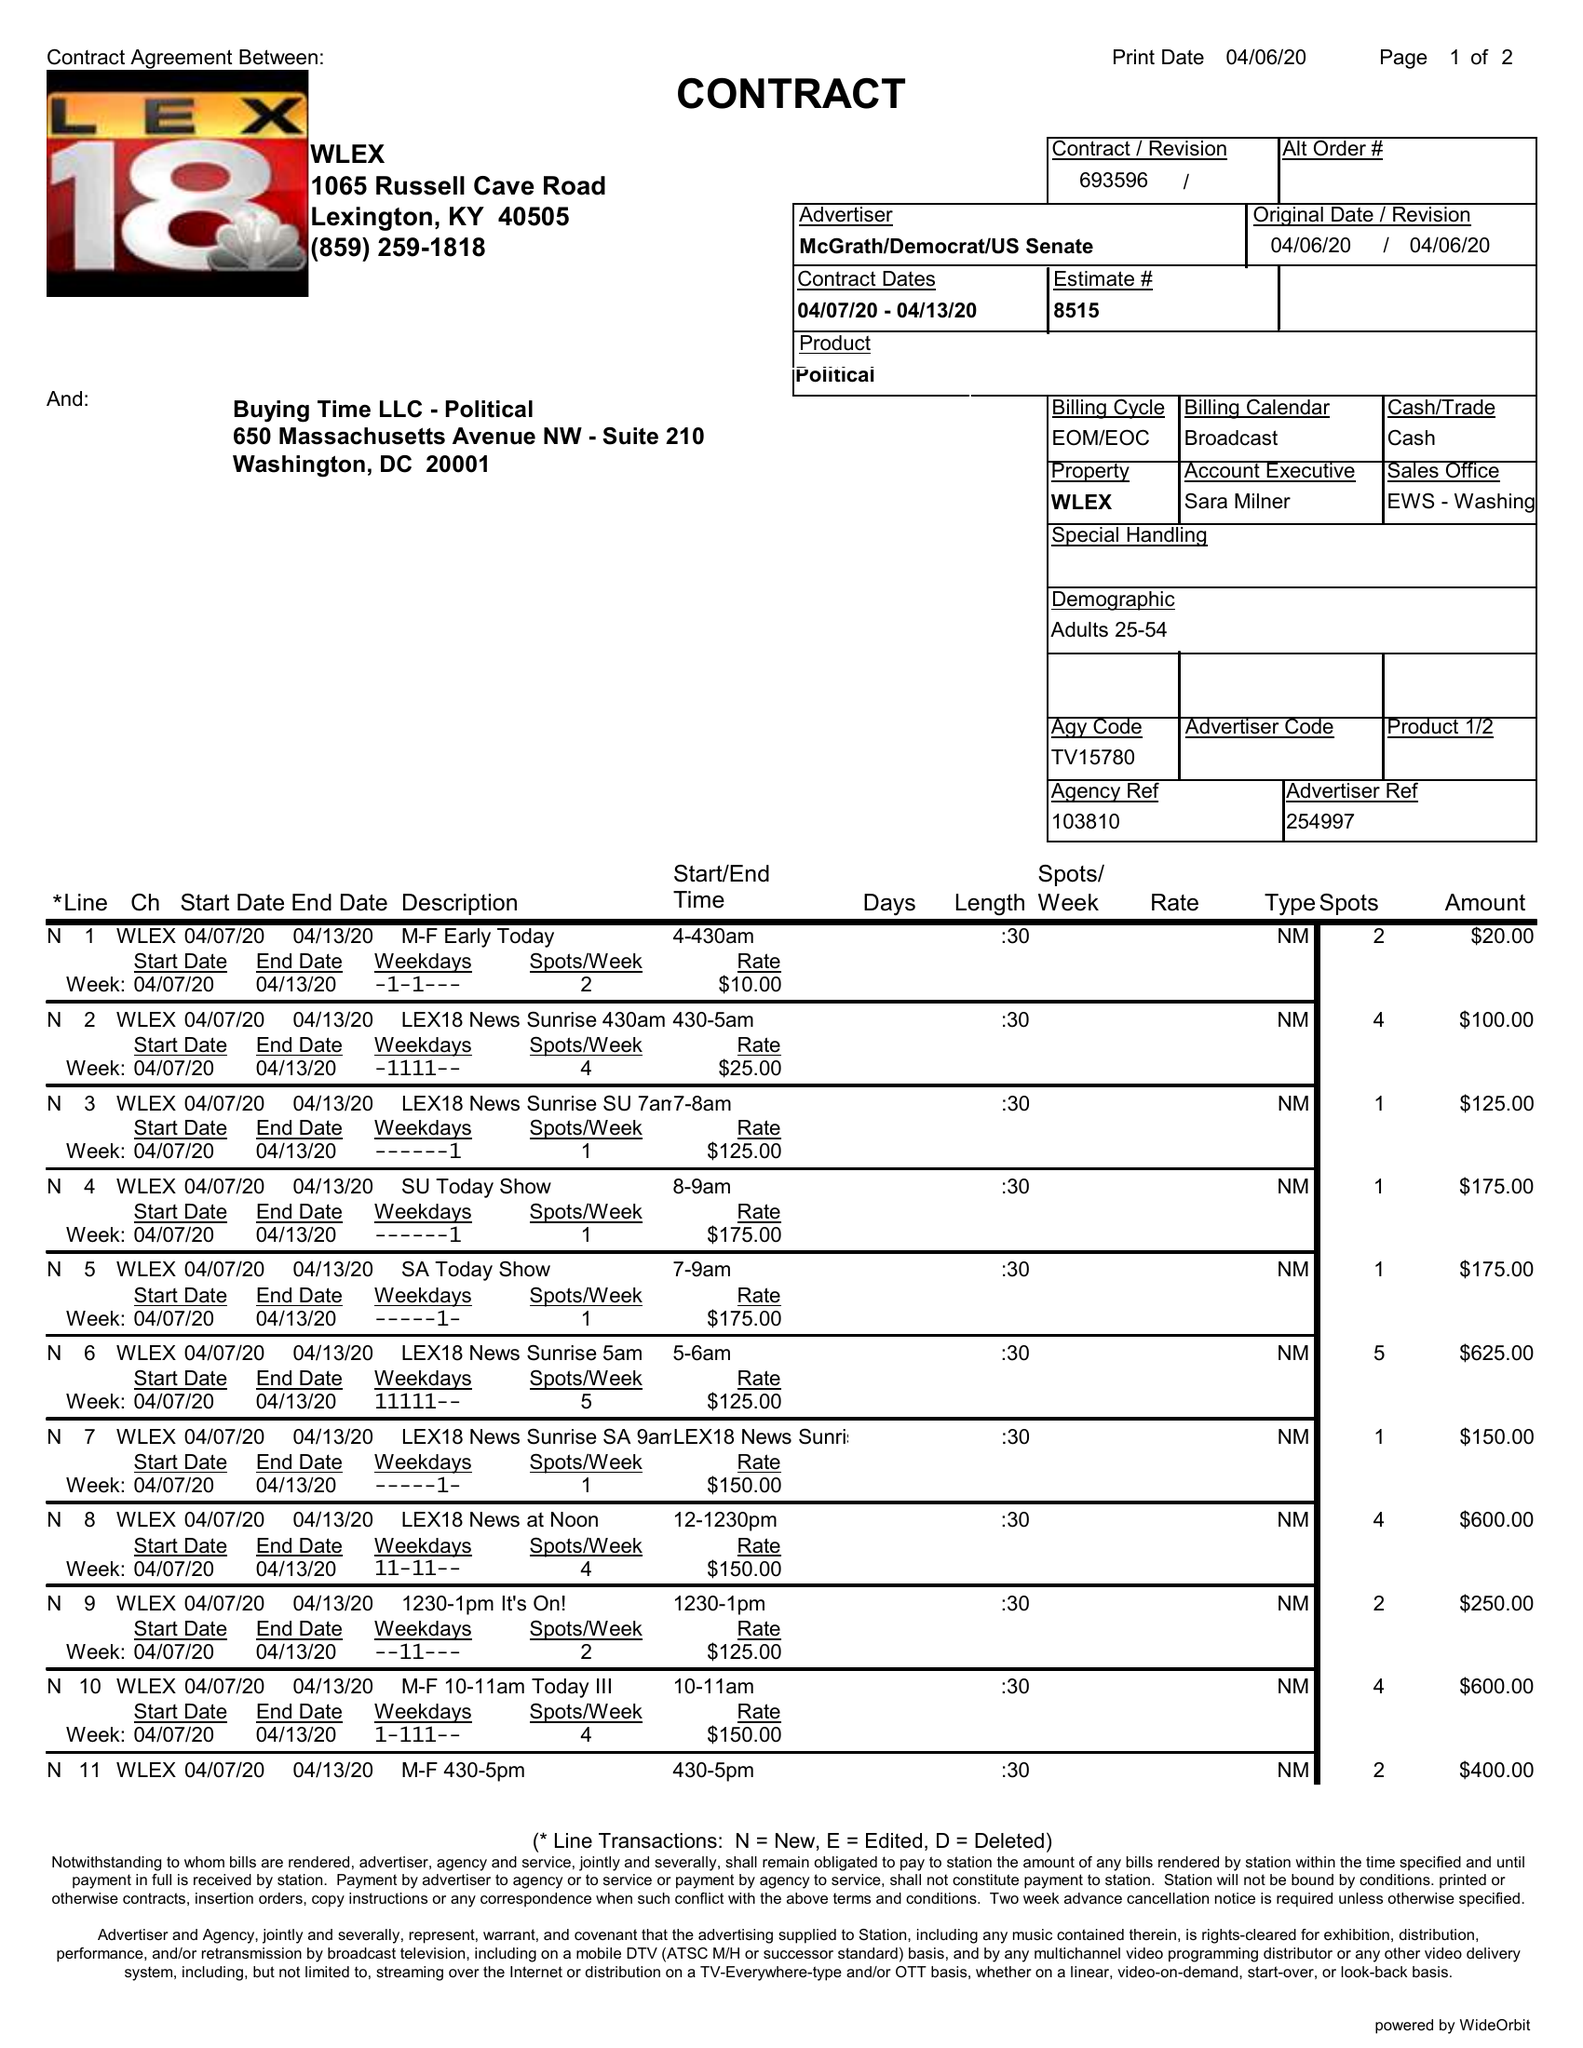What is the value for the gross_amount?
Answer the question using a single word or phrase. 8670.00 